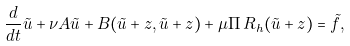<formula> <loc_0><loc_0><loc_500><loc_500>\frac { d } { d t } \tilde { u } + \nu A \tilde { u } + B ( \tilde { u } + z , \tilde { u } + z ) + \mu \Pi \, R _ { h } ( \tilde { u } + z ) = \tilde { f } ,</formula> 